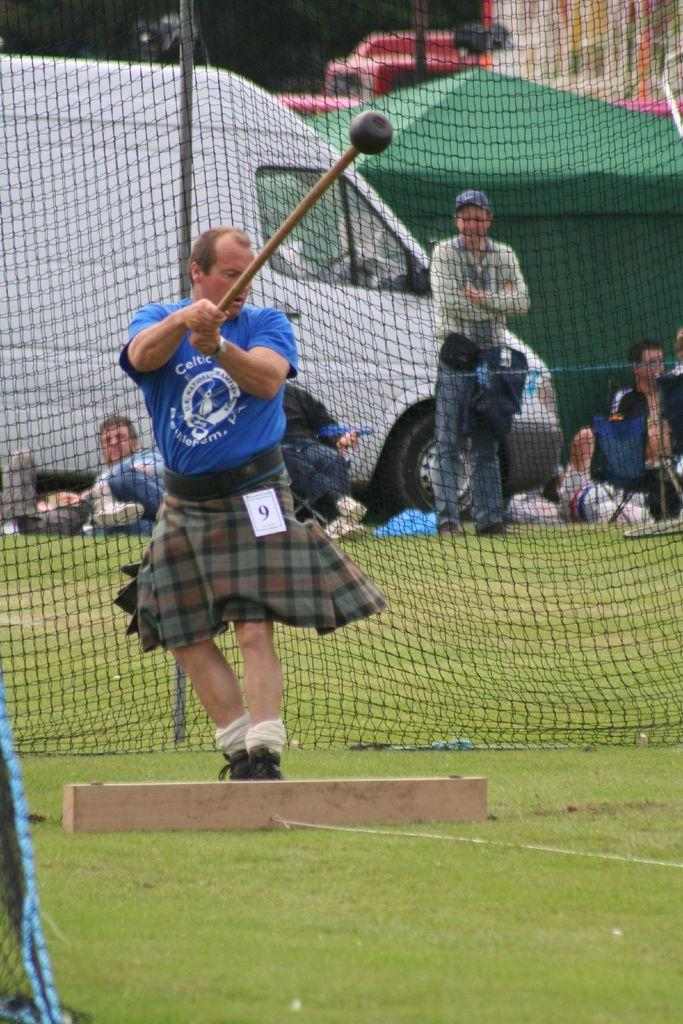Who is present in the image? There is a person in the image. What is the person wearing? The person is wearing clothes. What is the person standing in front of? The person is standing in front of a net. What is the person holding in their hand? The person is holding a stick. Are there any other people visible in the image? Yes, there are other persons visible in the image. What is located behind the net? There is a vehicle behind the net. What type of caption is written on the volcano in the image? There is no volcano present in the image, and therefore no caption can be found on it. How many beans are visible in the image? There are no beans present in the image. 